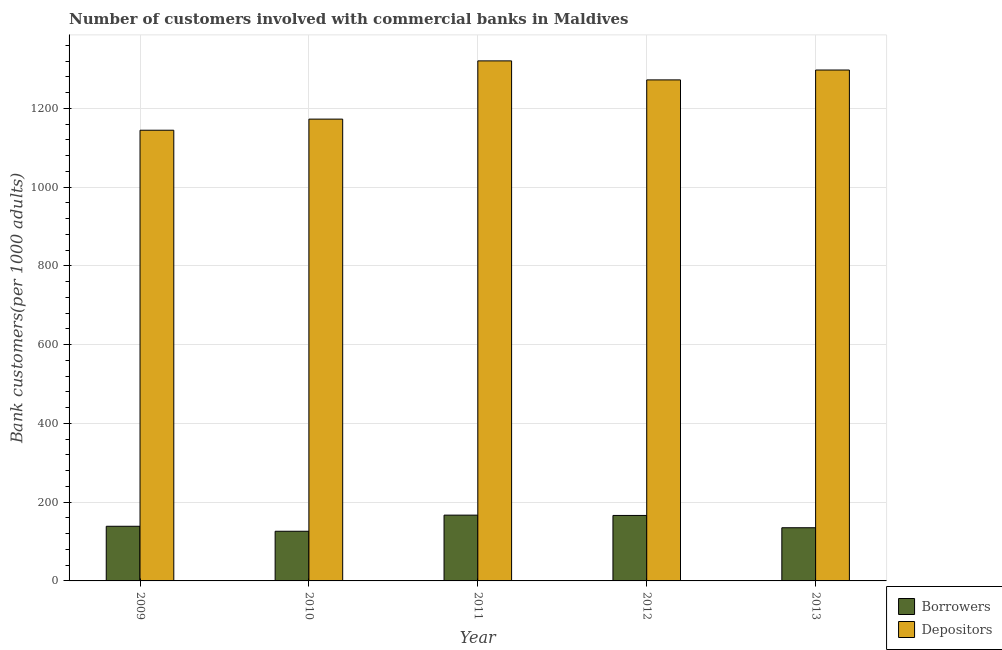How many different coloured bars are there?
Give a very brief answer. 2. How many groups of bars are there?
Keep it short and to the point. 5. What is the label of the 2nd group of bars from the left?
Your answer should be compact. 2010. In how many cases, is the number of bars for a given year not equal to the number of legend labels?
Your response must be concise. 0. What is the number of depositors in 2013?
Provide a short and direct response. 1297.48. Across all years, what is the maximum number of depositors?
Give a very brief answer. 1320.69. Across all years, what is the minimum number of borrowers?
Provide a short and direct response. 126.14. In which year was the number of depositors maximum?
Your answer should be very brief. 2011. What is the total number of depositors in the graph?
Give a very brief answer. 6207.91. What is the difference between the number of depositors in 2009 and that in 2012?
Offer a very short reply. -127.82. What is the difference between the number of borrowers in 2009 and the number of depositors in 2012?
Your answer should be very brief. -27.52. What is the average number of depositors per year?
Keep it short and to the point. 1241.58. In the year 2013, what is the difference between the number of borrowers and number of depositors?
Provide a succinct answer. 0. In how many years, is the number of borrowers greater than 1120?
Your response must be concise. 0. What is the ratio of the number of depositors in 2009 to that in 2011?
Keep it short and to the point. 0.87. Is the number of depositors in 2009 less than that in 2011?
Keep it short and to the point. Yes. Is the difference between the number of borrowers in 2012 and 2013 greater than the difference between the number of depositors in 2012 and 2013?
Provide a short and direct response. No. What is the difference between the highest and the second highest number of borrowers?
Provide a short and direct response. 0.78. What is the difference between the highest and the lowest number of borrowers?
Ensure brevity in your answer.  40.93. What does the 2nd bar from the left in 2009 represents?
Provide a short and direct response. Depositors. What does the 1st bar from the right in 2011 represents?
Your answer should be compact. Depositors. How many bars are there?
Your answer should be very brief. 10. What is the difference between two consecutive major ticks on the Y-axis?
Provide a short and direct response. 200. Are the values on the major ticks of Y-axis written in scientific E-notation?
Keep it short and to the point. No. Where does the legend appear in the graph?
Your answer should be compact. Bottom right. How are the legend labels stacked?
Your response must be concise. Vertical. What is the title of the graph?
Give a very brief answer. Number of customers involved with commercial banks in Maldives. What is the label or title of the Y-axis?
Offer a very short reply. Bank customers(per 1000 adults). What is the Bank customers(per 1000 adults) in Borrowers in 2009?
Keep it short and to the point. 138.77. What is the Bank customers(per 1000 adults) in Depositors in 2009?
Your response must be concise. 1144.57. What is the Bank customers(per 1000 adults) in Borrowers in 2010?
Ensure brevity in your answer.  126.14. What is the Bank customers(per 1000 adults) in Depositors in 2010?
Provide a succinct answer. 1172.79. What is the Bank customers(per 1000 adults) of Borrowers in 2011?
Offer a very short reply. 167.07. What is the Bank customers(per 1000 adults) of Depositors in 2011?
Your answer should be very brief. 1320.69. What is the Bank customers(per 1000 adults) of Borrowers in 2012?
Provide a short and direct response. 166.29. What is the Bank customers(per 1000 adults) of Depositors in 2012?
Provide a succinct answer. 1272.39. What is the Bank customers(per 1000 adults) in Borrowers in 2013?
Your answer should be compact. 135.04. What is the Bank customers(per 1000 adults) in Depositors in 2013?
Keep it short and to the point. 1297.48. Across all years, what is the maximum Bank customers(per 1000 adults) of Borrowers?
Provide a short and direct response. 167.07. Across all years, what is the maximum Bank customers(per 1000 adults) in Depositors?
Provide a succinct answer. 1320.69. Across all years, what is the minimum Bank customers(per 1000 adults) of Borrowers?
Provide a succinct answer. 126.14. Across all years, what is the minimum Bank customers(per 1000 adults) in Depositors?
Your answer should be very brief. 1144.57. What is the total Bank customers(per 1000 adults) of Borrowers in the graph?
Give a very brief answer. 733.3. What is the total Bank customers(per 1000 adults) of Depositors in the graph?
Ensure brevity in your answer.  6207.91. What is the difference between the Bank customers(per 1000 adults) of Borrowers in 2009 and that in 2010?
Your answer should be compact. 12.63. What is the difference between the Bank customers(per 1000 adults) of Depositors in 2009 and that in 2010?
Keep it short and to the point. -28.22. What is the difference between the Bank customers(per 1000 adults) of Borrowers in 2009 and that in 2011?
Ensure brevity in your answer.  -28.3. What is the difference between the Bank customers(per 1000 adults) in Depositors in 2009 and that in 2011?
Your answer should be very brief. -176.13. What is the difference between the Bank customers(per 1000 adults) of Borrowers in 2009 and that in 2012?
Make the answer very short. -27.52. What is the difference between the Bank customers(per 1000 adults) in Depositors in 2009 and that in 2012?
Provide a short and direct response. -127.82. What is the difference between the Bank customers(per 1000 adults) in Borrowers in 2009 and that in 2013?
Your response must be concise. 3.73. What is the difference between the Bank customers(per 1000 adults) of Depositors in 2009 and that in 2013?
Offer a terse response. -152.92. What is the difference between the Bank customers(per 1000 adults) in Borrowers in 2010 and that in 2011?
Provide a succinct answer. -40.93. What is the difference between the Bank customers(per 1000 adults) of Depositors in 2010 and that in 2011?
Ensure brevity in your answer.  -147.91. What is the difference between the Bank customers(per 1000 adults) of Borrowers in 2010 and that in 2012?
Provide a short and direct response. -40.15. What is the difference between the Bank customers(per 1000 adults) of Depositors in 2010 and that in 2012?
Keep it short and to the point. -99.6. What is the difference between the Bank customers(per 1000 adults) of Borrowers in 2010 and that in 2013?
Your answer should be compact. -8.9. What is the difference between the Bank customers(per 1000 adults) in Depositors in 2010 and that in 2013?
Provide a succinct answer. -124.7. What is the difference between the Bank customers(per 1000 adults) of Borrowers in 2011 and that in 2012?
Your answer should be compact. 0.78. What is the difference between the Bank customers(per 1000 adults) in Depositors in 2011 and that in 2012?
Provide a succinct answer. 48.3. What is the difference between the Bank customers(per 1000 adults) in Borrowers in 2011 and that in 2013?
Ensure brevity in your answer.  32.03. What is the difference between the Bank customers(per 1000 adults) of Depositors in 2011 and that in 2013?
Offer a very short reply. 23.21. What is the difference between the Bank customers(per 1000 adults) in Borrowers in 2012 and that in 2013?
Offer a very short reply. 31.25. What is the difference between the Bank customers(per 1000 adults) in Depositors in 2012 and that in 2013?
Provide a short and direct response. -25.1. What is the difference between the Bank customers(per 1000 adults) of Borrowers in 2009 and the Bank customers(per 1000 adults) of Depositors in 2010?
Your answer should be compact. -1034.02. What is the difference between the Bank customers(per 1000 adults) of Borrowers in 2009 and the Bank customers(per 1000 adults) of Depositors in 2011?
Your answer should be very brief. -1181.92. What is the difference between the Bank customers(per 1000 adults) of Borrowers in 2009 and the Bank customers(per 1000 adults) of Depositors in 2012?
Give a very brief answer. -1133.62. What is the difference between the Bank customers(per 1000 adults) of Borrowers in 2009 and the Bank customers(per 1000 adults) of Depositors in 2013?
Offer a terse response. -1158.72. What is the difference between the Bank customers(per 1000 adults) of Borrowers in 2010 and the Bank customers(per 1000 adults) of Depositors in 2011?
Provide a succinct answer. -1194.55. What is the difference between the Bank customers(per 1000 adults) in Borrowers in 2010 and the Bank customers(per 1000 adults) in Depositors in 2012?
Your response must be concise. -1146.25. What is the difference between the Bank customers(per 1000 adults) in Borrowers in 2010 and the Bank customers(per 1000 adults) in Depositors in 2013?
Ensure brevity in your answer.  -1171.35. What is the difference between the Bank customers(per 1000 adults) of Borrowers in 2011 and the Bank customers(per 1000 adults) of Depositors in 2012?
Give a very brief answer. -1105.32. What is the difference between the Bank customers(per 1000 adults) of Borrowers in 2011 and the Bank customers(per 1000 adults) of Depositors in 2013?
Offer a terse response. -1130.42. What is the difference between the Bank customers(per 1000 adults) in Borrowers in 2012 and the Bank customers(per 1000 adults) in Depositors in 2013?
Make the answer very short. -1131.19. What is the average Bank customers(per 1000 adults) in Borrowers per year?
Offer a very short reply. 146.66. What is the average Bank customers(per 1000 adults) of Depositors per year?
Make the answer very short. 1241.58. In the year 2009, what is the difference between the Bank customers(per 1000 adults) in Borrowers and Bank customers(per 1000 adults) in Depositors?
Provide a short and direct response. -1005.8. In the year 2010, what is the difference between the Bank customers(per 1000 adults) of Borrowers and Bank customers(per 1000 adults) of Depositors?
Make the answer very short. -1046.65. In the year 2011, what is the difference between the Bank customers(per 1000 adults) in Borrowers and Bank customers(per 1000 adults) in Depositors?
Your response must be concise. -1153.63. In the year 2012, what is the difference between the Bank customers(per 1000 adults) of Borrowers and Bank customers(per 1000 adults) of Depositors?
Your answer should be very brief. -1106.1. In the year 2013, what is the difference between the Bank customers(per 1000 adults) in Borrowers and Bank customers(per 1000 adults) in Depositors?
Your response must be concise. -1162.45. What is the ratio of the Bank customers(per 1000 adults) in Borrowers in 2009 to that in 2010?
Your answer should be compact. 1.1. What is the ratio of the Bank customers(per 1000 adults) of Depositors in 2009 to that in 2010?
Keep it short and to the point. 0.98. What is the ratio of the Bank customers(per 1000 adults) in Borrowers in 2009 to that in 2011?
Your answer should be very brief. 0.83. What is the ratio of the Bank customers(per 1000 adults) of Depositors in 2009 to that in 2011?
Offer a terse response. 0.87. What is the ratio of the Bank customers(per 1000 adults) of Borrowers in 2009 to that in 2012?
Your response must be concise. 0.83. What is the ratio of the Bank customers(per 1000 adults) in Depositors in 2009 to that in 2012?
Your response must be concise. 0.9. What is the ratio of the Bank customers(per 1000 adults) of Borrowers in 2009 to that in 2013?
Provide a succinct answer. 1.03. What is the ratio of the Bank customers(per 1000 adults) of Depositors in 2009 to that in 2013?
Offer a terse response. 0.88. What is the ratio of the Bank customers(per 1000 adults) in Borrowers in 2010 to that in 2011?
Offer a terse response. 0.76. What is the ratio of the Bank customers(per 1000 adults) in Depositors in 2010 to that in 2011?
Give a very brief answer. 0.89. What is the ratio of the Bank customers(per 1000 adults) of Borrowers in 2010 to that in 2012?
Keep it short and to the point. 0.76. What is the ratio of the Bank customers(per 1000 adults) in Depositors in 2010 to that in 2012?
Give a very brief answer. 0.92. What is the ratio of the Bank customers(per 1000 adults) in Borrowers in 2010 to that in 2013?
Your answer should be very brief. 0.93. What is the ratio of the Bank customers(per 1000 adults) in Depositors in 2010 to that in 2013?
Provide a short and direct response. 0.9. What is the ratio of the Bank customers(per 1000 adults) in Borrowers in 2011 to that in 2012?
Your answer should be compact. 1. What is the ratio of the Bank customers(per 1000 adults) of Depositors in 2011 to that in 2012?
Offer a terse response. 1.04. What is the ratio of the Bank customers(per 1000 adults) of Borrowers in 2011 to that in 2013?
Ensure brevity in your answer.  1.24. What is the ratio of the Bank customers(per 1000 adults) in Depositors in 2011 to that in 2013?
Provide a short and direct response. 1.02. What is the ratio of the Bank customers(per 1000 adults) in Borrowers in 2012 to that in 2013?
Your answer should be very brief. 1.23. What is the ratio of the Bank customers(per 1000 adults) in Depositors in 2012 to that in 2013?
Offer a very short reply. 0.98. What is the difference between the highest and the second highest Bank customers(per 1000 adults) in Borrowers?
Provide a short and direct response. 0.78. What is the difference between the highest and the second highest Bank customers(per 1000 adults) of Depositors?
Offer a very short reply. 23.21. What is the difference between the highest and the lowest Bank customers(per 1000 adults) in Borrowers?
Your answer should be compact. 40.93. What is the difference between the highest and the lowest Bank customers(per 1000 adults) in Depositors?
Offer a terse response. 176.13. 